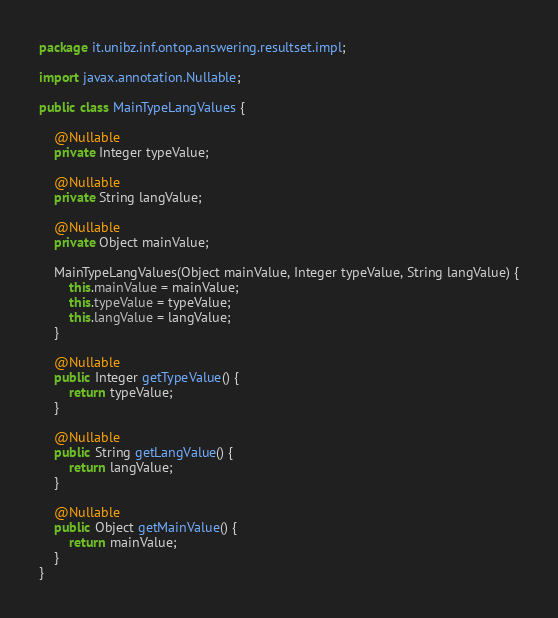<code> <loc_0><loc_0><loc_500><loc_500><_Java_>package it.unibz.inf.ontop.answering.resultset.impl;

import javax.annotation.Nullable;

public class MainTypeLangValues {

    @Nullable
    private Integer typeValue;

    @Nullable
    private String langValue;

    @Nullable
    private Object mainValue;

    MainTypeLangValues(Object mainValue, Integer typeValue, String langValue) {
        this.mainValue = mainValue;
        this.typeValue = typeValue;
        this.langValue = langValue;
    }

    @Nullable
    public Integer getTypeValue() {
        return typeValue;
    }

    @Nullable
    public String getLangValue() {
        return langValue;
    }

    @Nullable
    public Object getMainValue() {
        return mainValue;
    }
}

</code> 